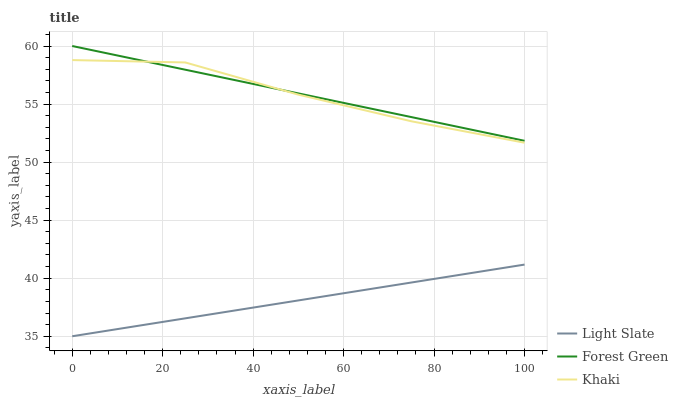Does Light Slate have the minimum area under the curve?
Answer yes or no. Yes. Does Forest Green have the maximum area under the curve?
Answer yes or no. Yes. Does Khaki have the minimum area under the curve?
Answer yes or no. No. Does Khaki have the maximum area under the curve?
Answer yes or no. No. Is Light Slate the smoothest?
Answer yes or no. Yes. Is Khaki the roughest?
Answer yes or no. Yes. Is Forest Green the smoothest?
Answer yes or no. No. Is Forest Green the roughest?
Answer yes or no. No. Does Light Slate have the lowest value?
Answer yes or no. Yes. Does Khaki have the lowest value?
Answer yes or no. No. Does Forest Green have the highest value?
Answer yes or no. Yes. Does Khaki have the highest value?
Answer yes or no. No. Is Light Slate less than Khaki?
Answer yes or no. Yes. Is Khaki greater than Light Slate?
Answer yes or no. Yes. Does Forest Green intersect Khaki?
Answer yes or no. Yes. Is Forest Green less than Khaki?
Answer yes or no. No. Is Forest Green greater than Khaki?
Answer yes or no. No. Does Light Slate intersect Khaki?
Answer yes or no. No. 